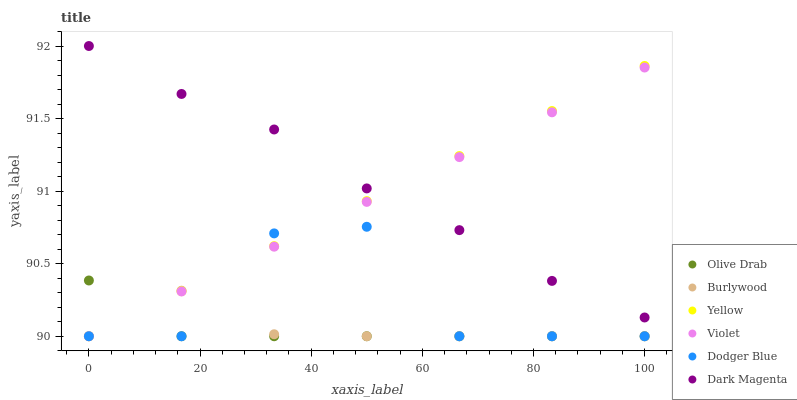Does Olive Drab have the minimum area under the curve?
Answer yes or no. Yes. Does Dark Magenta have the maximum area under the curve?
Answer yes or no. Yes. Does Burlywood have the minimum area under the curve?
Answer yes or no. No. Does Burlywood have the maximum area under the curve?
Answer yes or no. No. Is Yellow the smoothest?
Answer yes or no. Yes. Is Dodger Blue the roughest?
Answer yes or no. Yes. Is Burlywood the smoothest?
Answer yes or no. No. Is Burlywood the roughest?
Answer yes or no. No. Does Burlywood have the lowest value?
Answer yes or no. Yes. Does Dark Magenta have the highest value?
Answer yes or no. Yes. Does Yellow have the highest value?
Answer yes or no. No. Is Burlywood less than Dark Magenta?
Answer yes or no. Yes. Is Dark Magenta greater than Burlywood?
Answer yes or no. Yes. Does Violet intersect Burlywood?
Answer yes or no. Yes. Is Violet less than Burlywood?
Answer yes or no. No. Is Violet greater than Burlywood?
Answer yes or no. No. Does Burlywood intersect Dark Magenta?
Answer yes or no. No. 